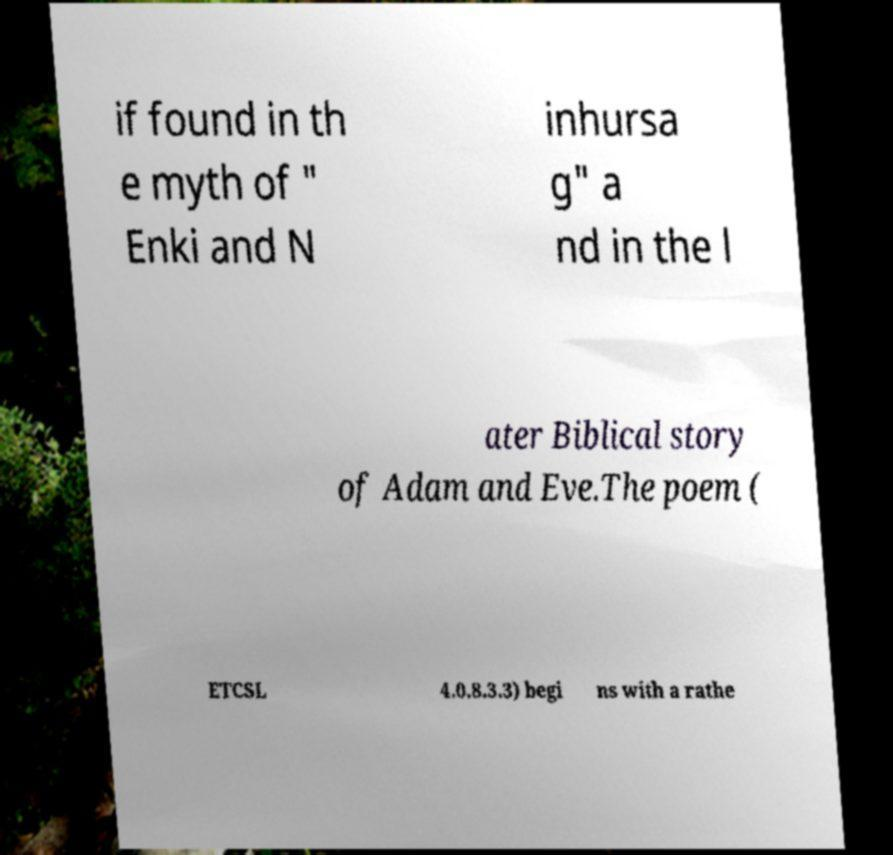Can you accurately transcribe the text from the provided image for me? if found in th e myth of " Enki and N inhursa g" a nd in the l ater Biblical story of Adam and Eve.The poem ( ETCSL 4.0.8.3.3) begi ns with a rathe 